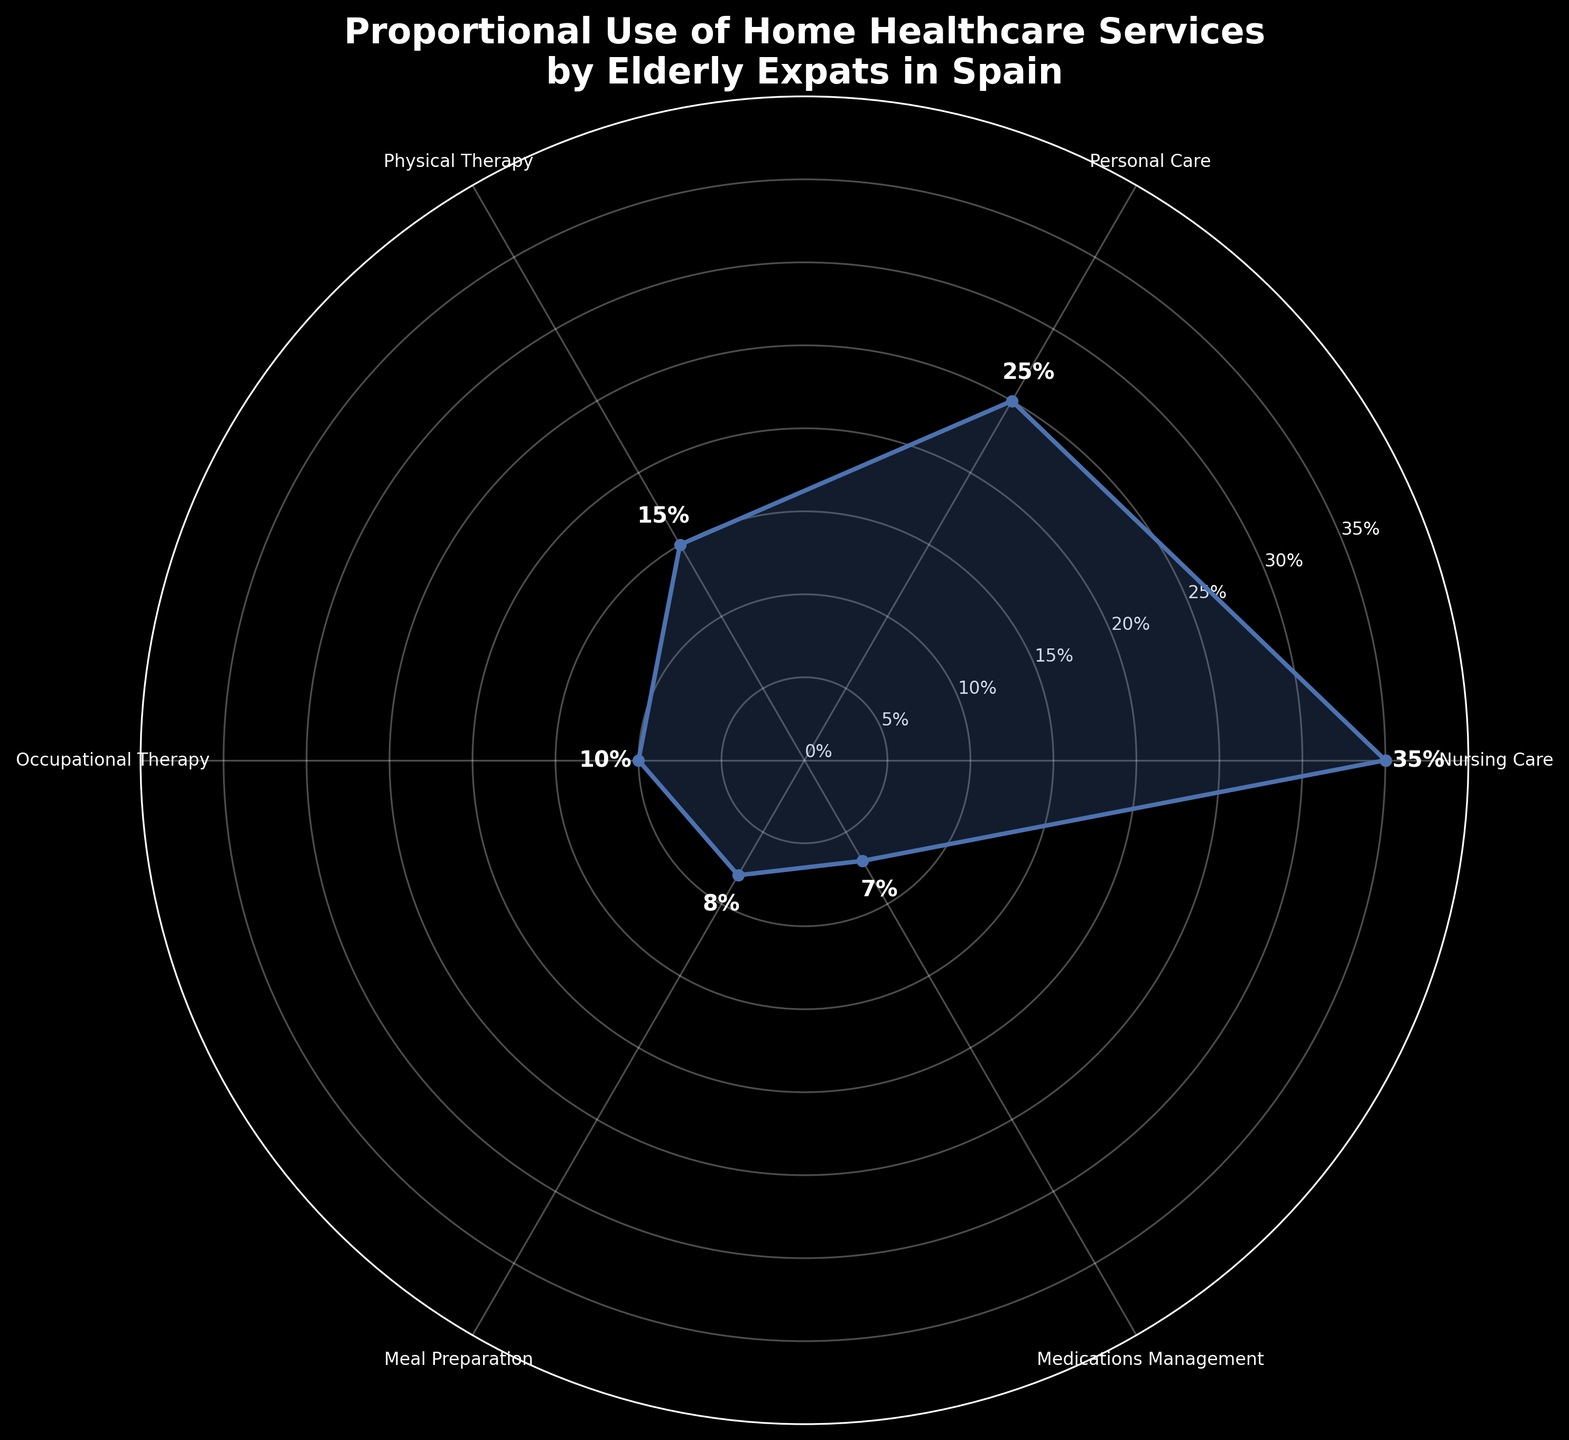What is the title of the chart? The title is displayed prominently at the top of the chart within a polar area chart. It is usually in a larger font size and may also be bold.
Answer: Proportional Use of Home Healthcare Services by Elderly Expats in Spain What percentage of usage does Nursing Care account for? Nursing Care is represented as one of the segments in the chart. By looking at the chart, we can see the percentage label next to it.
Answer: 35% Which service has the least percentage of usage? By observing the sizes of the segments in the chart and the associated percentage labels, the service with the smallest segment and percentage can be identified.
Answer: Medications Management What is the combined percentage of Nursing Care and Personal Care? To find the combined percentage, we need to sum the individual usage percentages of Nursing Care and Personal Care which are 35% and 25%, respectively.
Answer: 60% Which two services have usage percentages that are closest to each other? We look at the percentage labels for each service and identify the two services with the smallest absolute difference between their percentages. Medications Management (7%) and Meal Preparation (8%) have only a 1% difference.
Answer: Medications Management and Meal Preparation How much more usage does Nursing Care have compared to Physical Therapy? The difference in usage percentages between Nursing Care (35%) and Physical Therapy (15%) is calculated by subtracting the smaller percentage from the larger one.
Answer: 20% Which service usage is exactly 10%? By looking at the percentage labels for each segment, the service that has a label indicating 10% is identified.
Answer: Occupational Therapy What is the average usage percentage of all services? To find the average, add up all the usage percentages and divide by the number of services: (35 + 25 + 15 + 10 + 8 + 7) / 6 = 100 / 6 = 16.67%
Answer: 16.67% Are there any services that make up more than 30% of the total usage? By checking the percentage labels around the chart, we verify if any service has a usage percentage above 30%. Nursing Care is the only service that qualifies.
Answer: Yes, Nursing Care Which service is used more: Meal Preparation or Personal Care? By comparing the percentage labels of Meal Preparation (8%) and Personal Care (25%), we identify which has a greater value.
Answer: Personal Care 